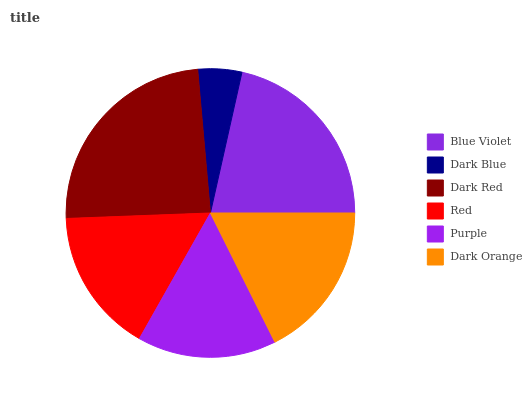Is Dark Blue the minimum?
Answer yes or no. Yes. Is Dark Red the maximum?
Answer yes or no. Yes. Is Dark Red the minimum?
Answer yes or no. No. Is Dark Blue the maximum?
Answer yes or no. No. Is Dark Red greater than Dark Blue?
Answer yes or no. Yes. Is Dark Blue less than Dark Red?
Answer yes or no. Yes. Is Dark Blue greater than Dark Red?
Answer yes or no. No. Is Dark Red less than Dark Blue?
Answer yes or no. No. Is Dark Orange the high median?
Answer yes or no. Yes. Is Red the low median?
Answer yes or no. Yes. Is Dark Blue the high median?
Answer yes or no. No. Is Dark Orange the low median?
Answer yes or no. No. 